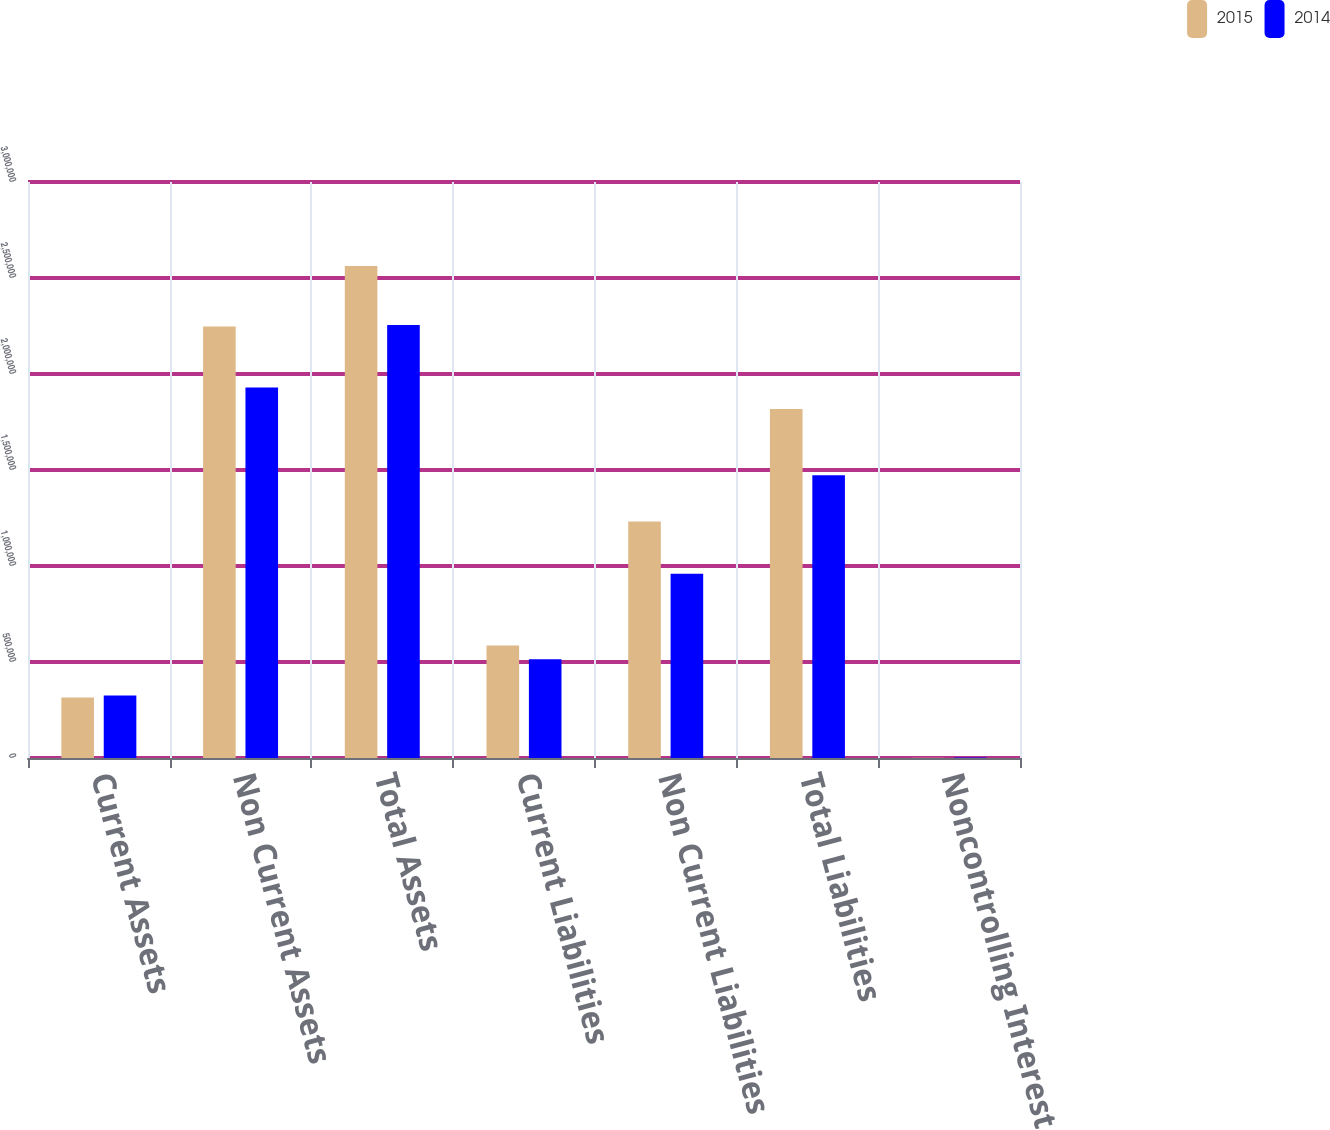Convert chart to OTSL. <chart><loc_0><loc_0><loc_500><loc_500><stacked_bar_chart><ecel><fcel>Current Assets<fcel>Non Current Assets<fcel>Total Assets<fcel>Current Liabilities<fcel>Non Current Liabilities<fcel>Total Liabilities<fcel>Noncontrolling Interest<nl><fcel>2015<fcel>315264<fcel>2.24681e+06<fcel>2.56207e+06<fcel>585887<fcel>1.23126e+06<fcel>1.81715e+06<fcel>1683<nl><fcel>2014<fcel>325527<fcel>1.92918e+06<fcel>2.25471e+06<fcel>513842<fcel>958988<fcel>1.47283e+06<fcel>2795<nl></chart> 